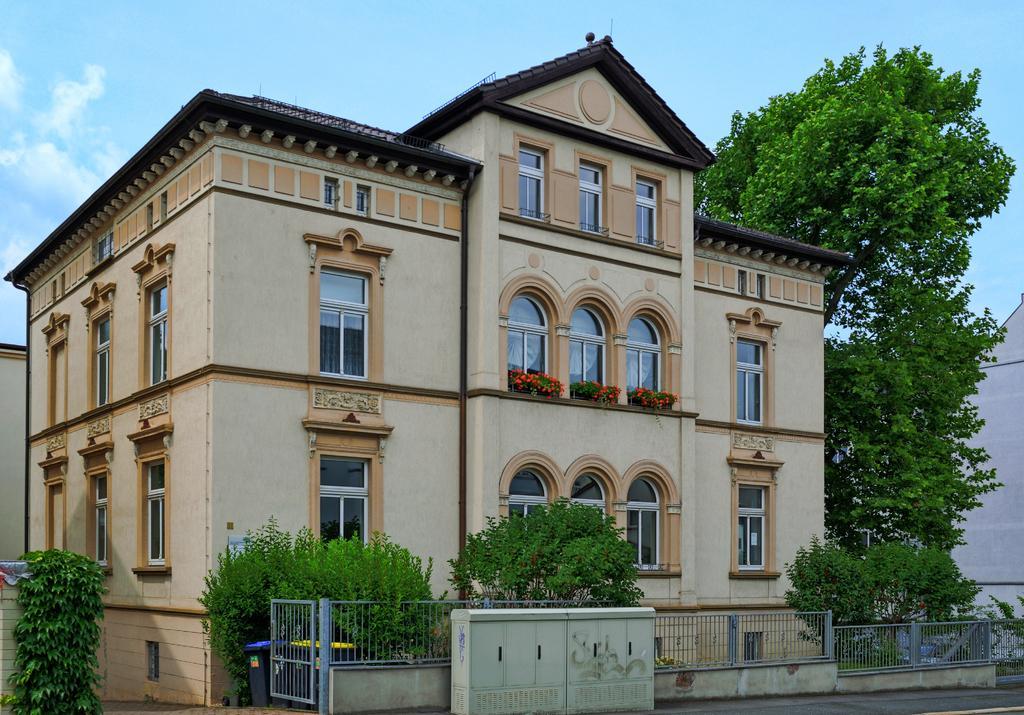Can you describe this image briefly? In this image in the center there are plants and there is a fence. In front of the fence there is an object which is white in colour. In the background there are buildings and there are trees. On the right side there is a wall and the sky is cloudy. 